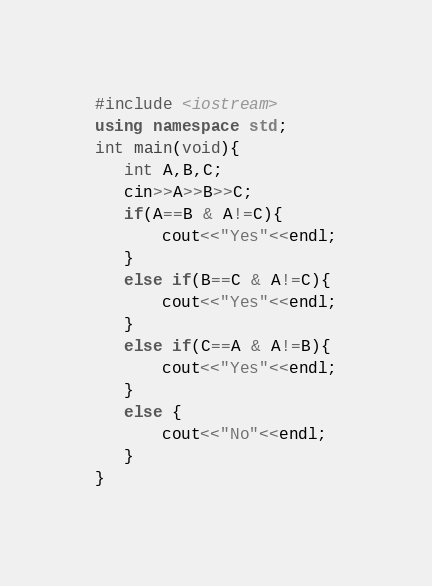Convert code to text. <code><loc_0><loc_0><loc_500><loc_500><_C++_>#include <iostream>
using namespace std;
int main(void){
   int A,B,C;
   cin>>A>>B>>C;
   if(A==B & A!=C){
       cout<<"Yes"<<endl;
   }
   else if(B==C & A!=C){
       cout<<"Yes"<<endl;
   }
   else if(C==A & A!=B){
       cout<<"Yes"<<endl;
   }
   else {
       cout<<"No"<<endl;
   }
}
</code> 